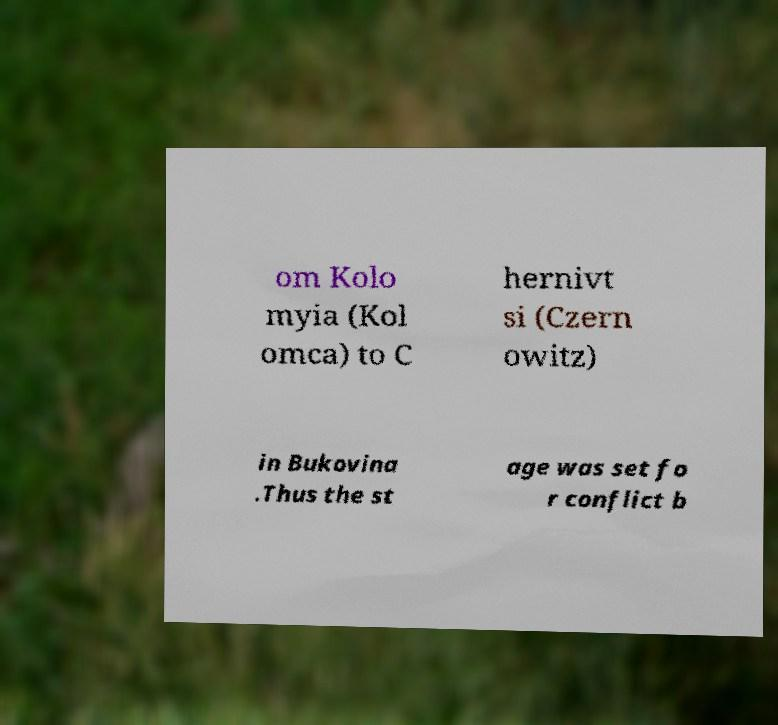There's text embedded in this image that I need extracted. Can you transcribe it verbatim? om Kolo myia (Kol omca) to C hernivt si (Czern owitz) in Bukovina .Thus the st age was set fo r conflict b 